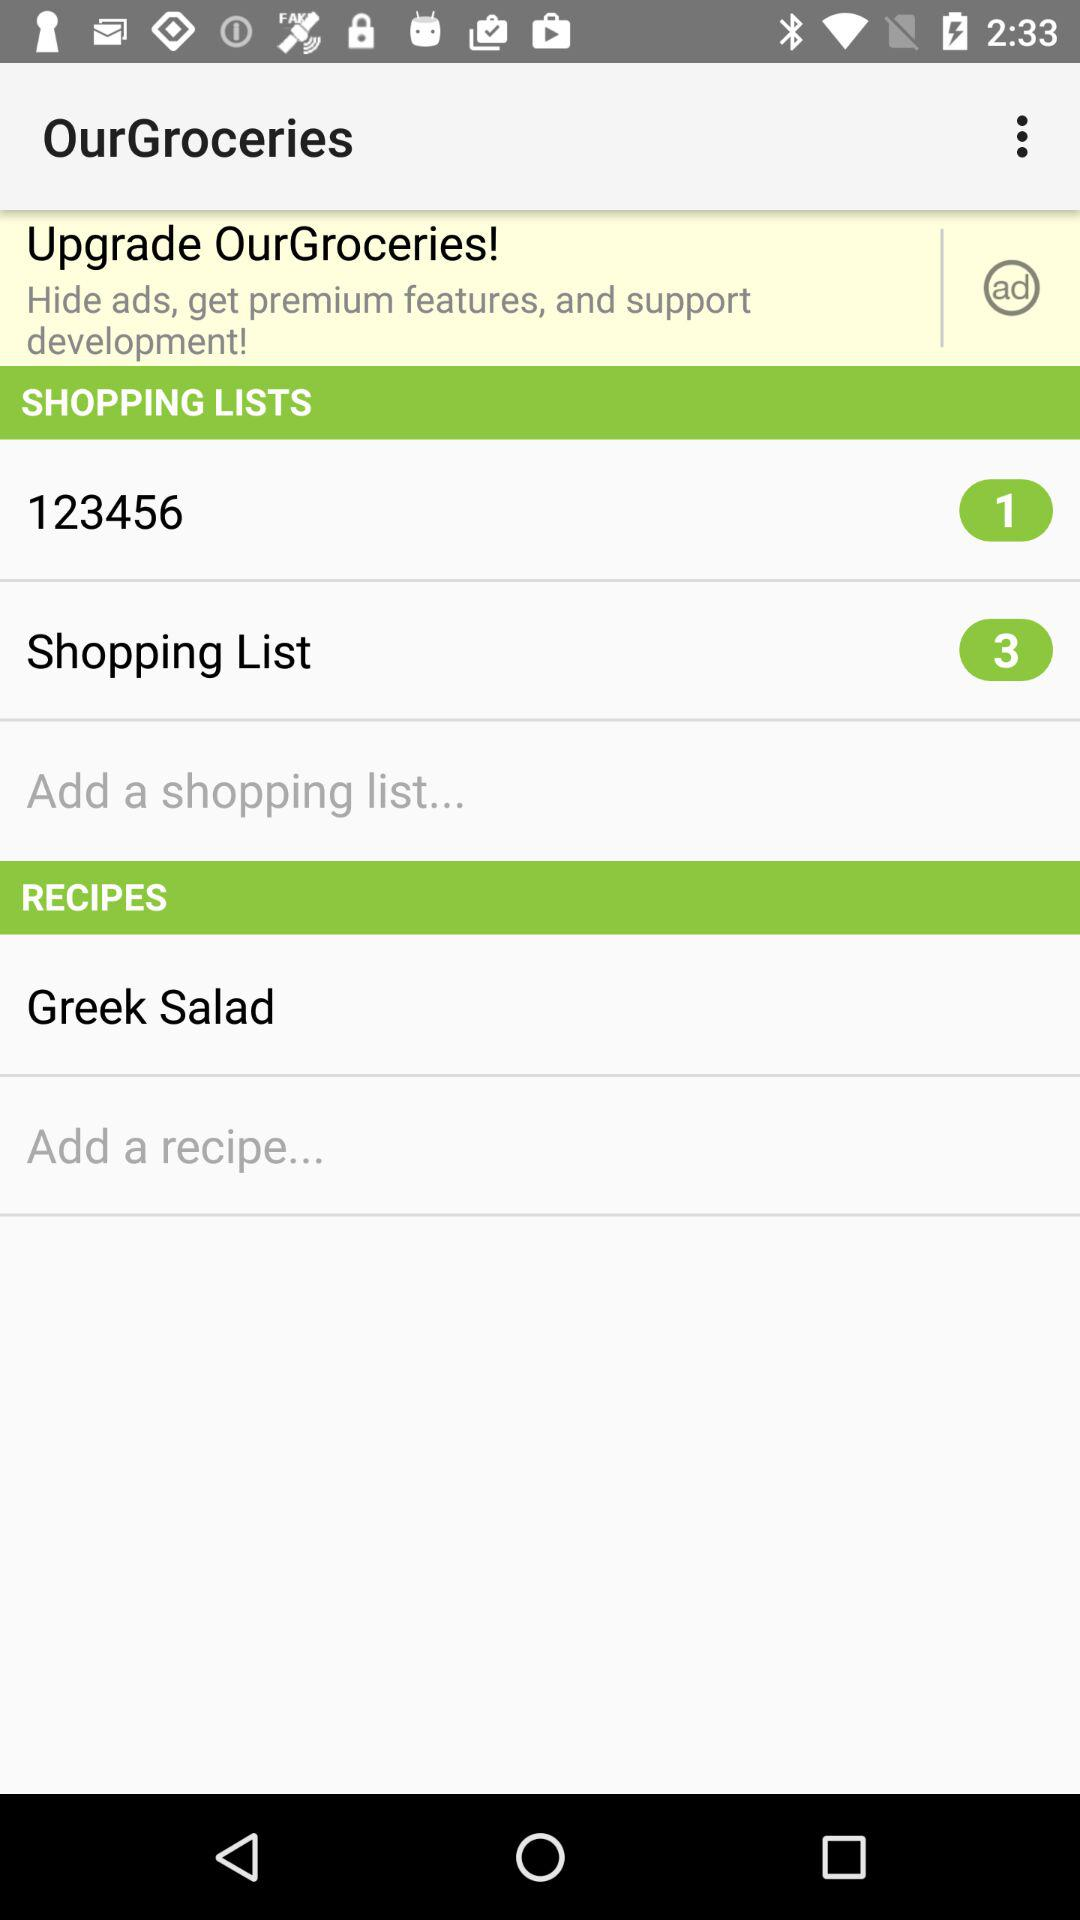How many items are there in the list named "Shopping List"? There are 3 items in the list named "Shopping List". 